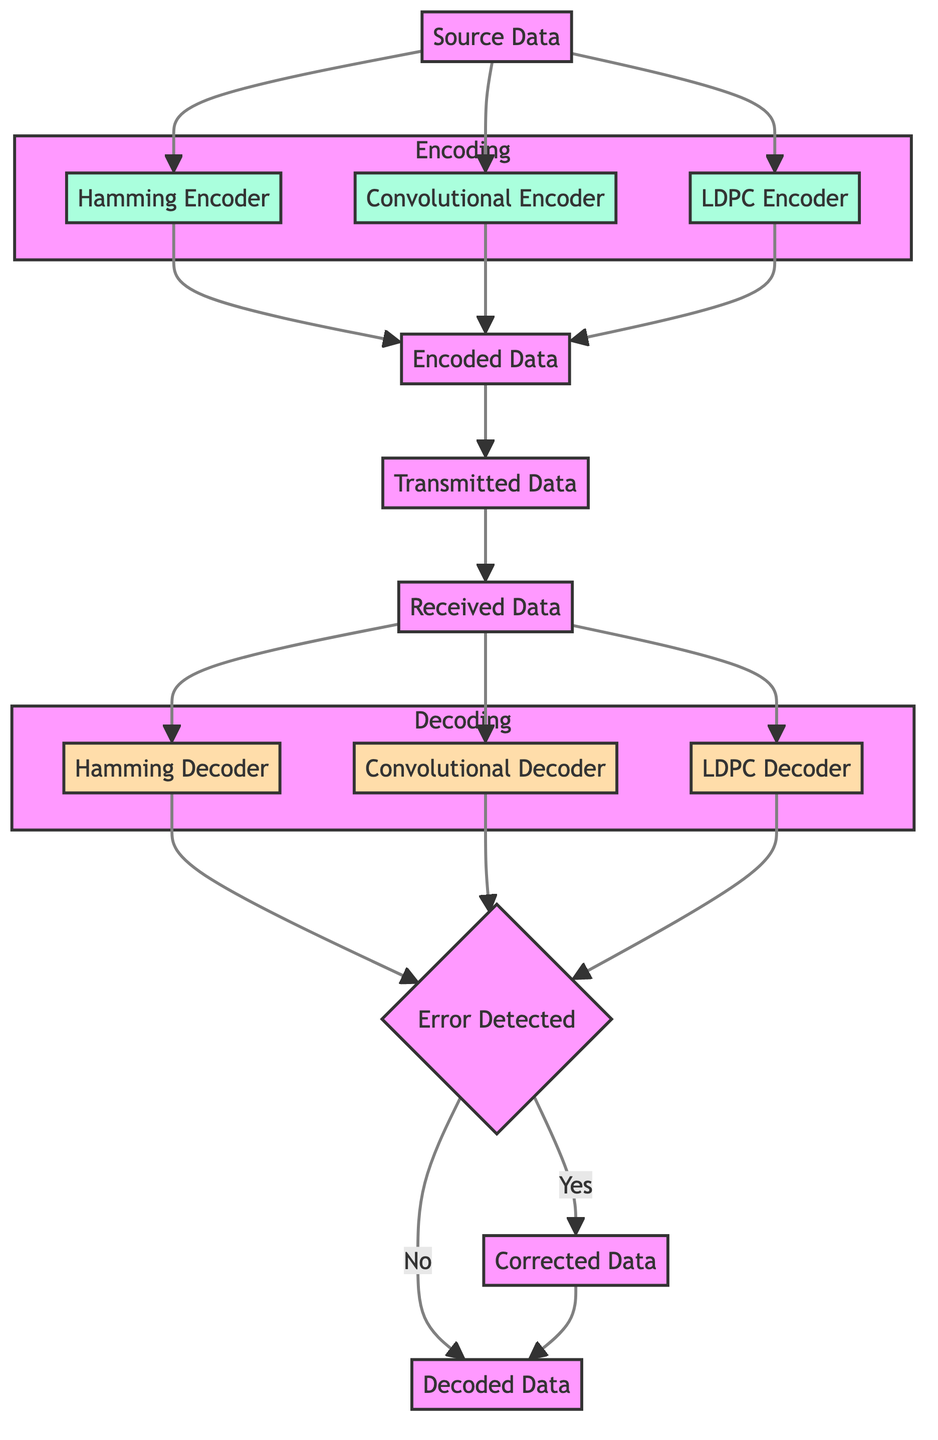What are the three encoding techniques depicted in the diagram? The diagram lists Hamming Code, Convolutional Code, and LDPC Codes as the three encoding techniques under the Encoding subgraph.
Answer: Hamming Code, Convolutional Code, LDPC Codes How many decoders are shown in the diagram? The diagram contains three decoders: Hamming Decoder, Convolutional Decoder, and LDPC Decoder, which are placed under the Decoding subgraph.
Answer: 3 What is the output of the Hamming Encoder? The output of the Hamming Encoder, as indicated in the diagram, goes to the Encoded Data node, which is the next step after encoding the source data.
Answer: Encoded Data What happens when an error is detected in the received data? According to the diagram, if an error is detected, the process continues to output Corrected Data, followed by Decoded Data; if no error is detected, it directly outputs Decoded Data.
Answer: Corrected Data Which node follows the Transmitted Data in the flow? The next node after Transmitted Data, as shown in the diagram, is the Received Data node, to which transmitted data is sent.
Answer: Received Data What is the initial input to the encoding process? The initial input to the encoding process is labeled as Source Data in the diagram, which is represented at the top before it branches out to different encoders.
Answer: Source Data What is the final output of the decoding process? The final output at the end of the decoding process, indicated in the diagram, is Decoded Data, which is reached after error detection.
Answer: Decoded Data If an error was detected during the process, which node will the flow lead to before outputting Decoded Data? If an error is detected (as per the flow indicated), the process will lead to Corrected Data before it outputs Decoded Data.
Answer: Corrected Data How many nodes are part of the Encoding subgraph? The Encoding subgraph consists of three nodes: Hamming Encoder, Convolutional Encoder, and LDPC Encoder, as shown in the diagram.
Answer: 3 